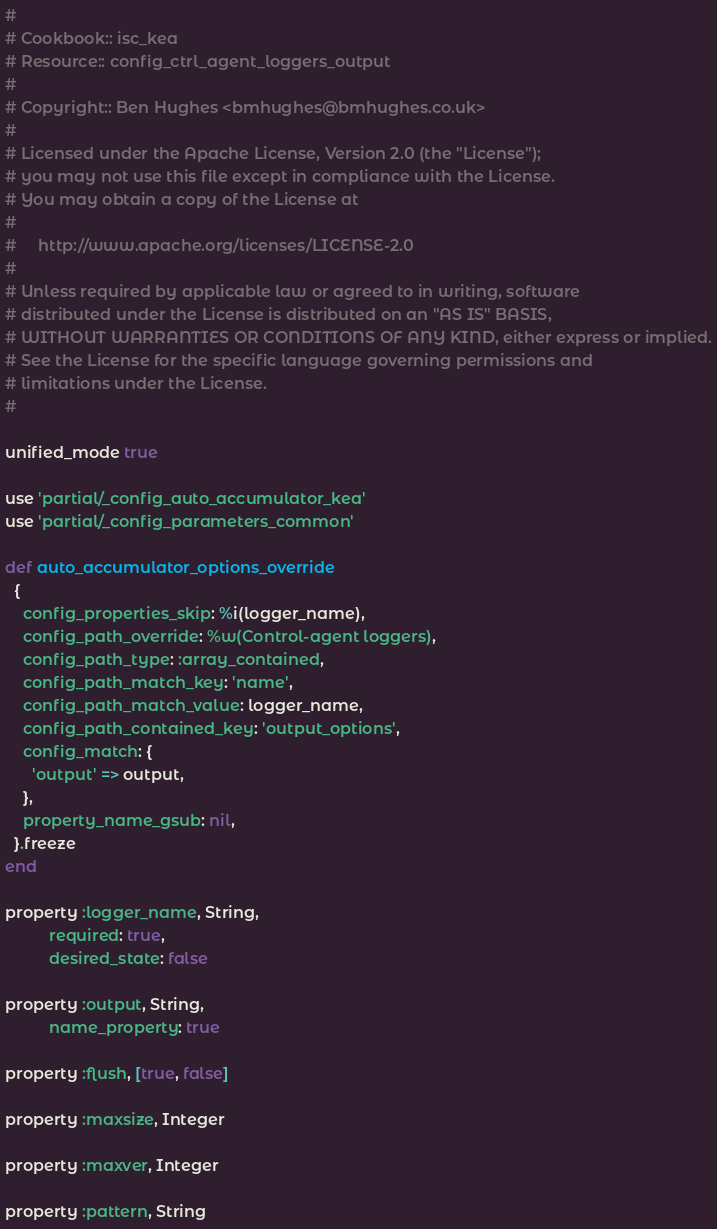Convert code to text. <code><loc_0><loc_0><loc_500><loc_500><_Ruby_>#
# Cookbook:: isc_kea
# Resource:: config_ctrl_agent_loggers_output
#
# Copyright:: Ben Hughes <bmhughes@bmhughes.co.uk>
#
# Licensed under the Apache License, Version 2.0 (the "License");
# you may not use this file except in compliance with the License.
# You may obtain a copy of the License at
#
#     http://www.apache.org/licenses/LICENSE-2.0
#
# Unless required by applicable law or agreed to in writing, software
# distributed under the License is distributed on an "AS IS" BASIS,
# WITHOUT WARRANTIES OR CONDITIONS OF ANY KIND, either express or implied.
# See the License for the specific language governing permissions and
# limitations under the License.
#

unified_mode true

use 'partial/_config_auto_accumulator_kea'
use 'partial/_config_parameters_common'

def auto_accumulator_options_override
  {
    config_properties_skip: %i(logger_name),
    config_path_override: %w(Control-agent loggers),
    config_path_type: :array_contained,
    config_path_match_key: 'name',
    config_path_match_value: logger_name,
    config_path_contained_key: 'output_options',
    config_match: {
      'output' => output,
    },
    property_name_gsub: nil,
  }.freeze
end

property :logger_name, String,
          required: true,
          desired_state: false

property :output, String,
          name_property: true

property :flush, [true, false]

property :maxsize, Integer

property :maxver, Integer

property :pattern, String
</code> 